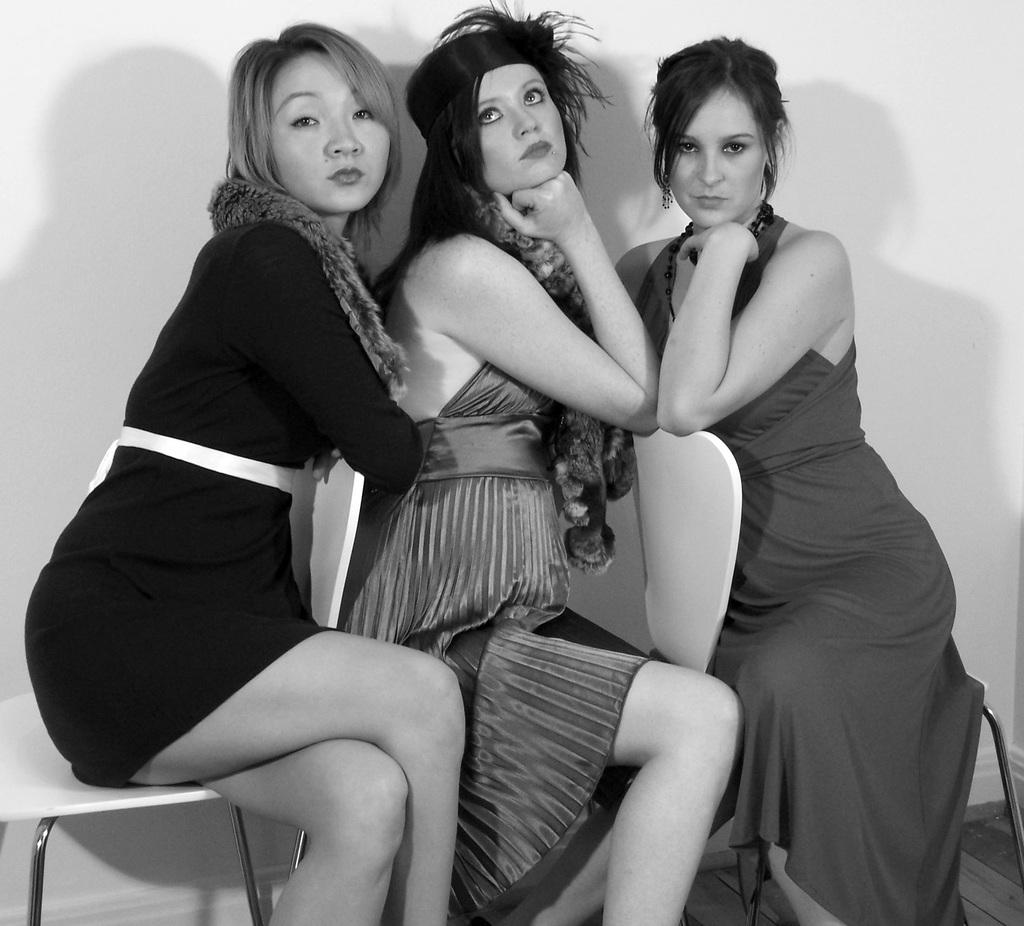How many people are in the image? There are three women in the image. What are the women doing in the image? The women are sitting in chairs. What is the color scheme of the image? The image is black and white. What can be seen in the background of the image? There is a wall in the background of the image. What type of weather can be seen in the image? The image is black and white, so it is not possible to determine the weather from the image. What kind of machine is being operated by the women in the image? There is no machine present in the image; the women are simply sitting in chairs. 